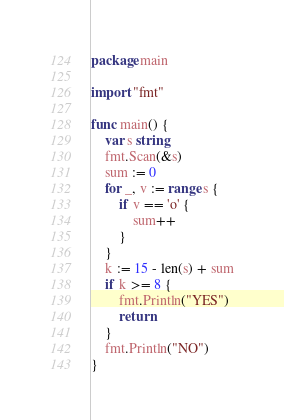<code> <loc_0><loc_0><loc_500><loc_500><_Go_>package main

import "fmt"

func main() {
	var s string
	fmt.Scan(&s)
	sum := 0
	for _, v := range s {
		if v == 'o' {
			sum++
		}
	}
	k := 15 - len(s) + sum
	if k >= 8 {
		fmt.Println("YES")
		return
	}
	fmt.Println("NO")
}
</code> 